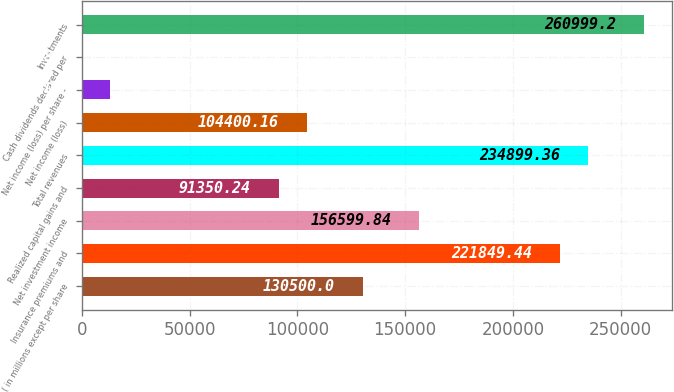<chart> <loc_0><loc_0><loc_500><loc_500><bar_chart><fcel>( in millions except per share<fcel>Insurance premiums and<fcel>Net investment income<fcel>Realized capital gains and<fcel>Total revenues<fcel>Net income (loss)<fcel>Net income (loss) per share -<fcel>Cash dividends declared per<fcel>Investments<nl><fcel>130500<fcel>221849<fcel>156600<fcel>91350.2<fcel>234899<fcel>104400<fcel>13050.7<fcel>0.8<fcel>260999<nl></chart> 